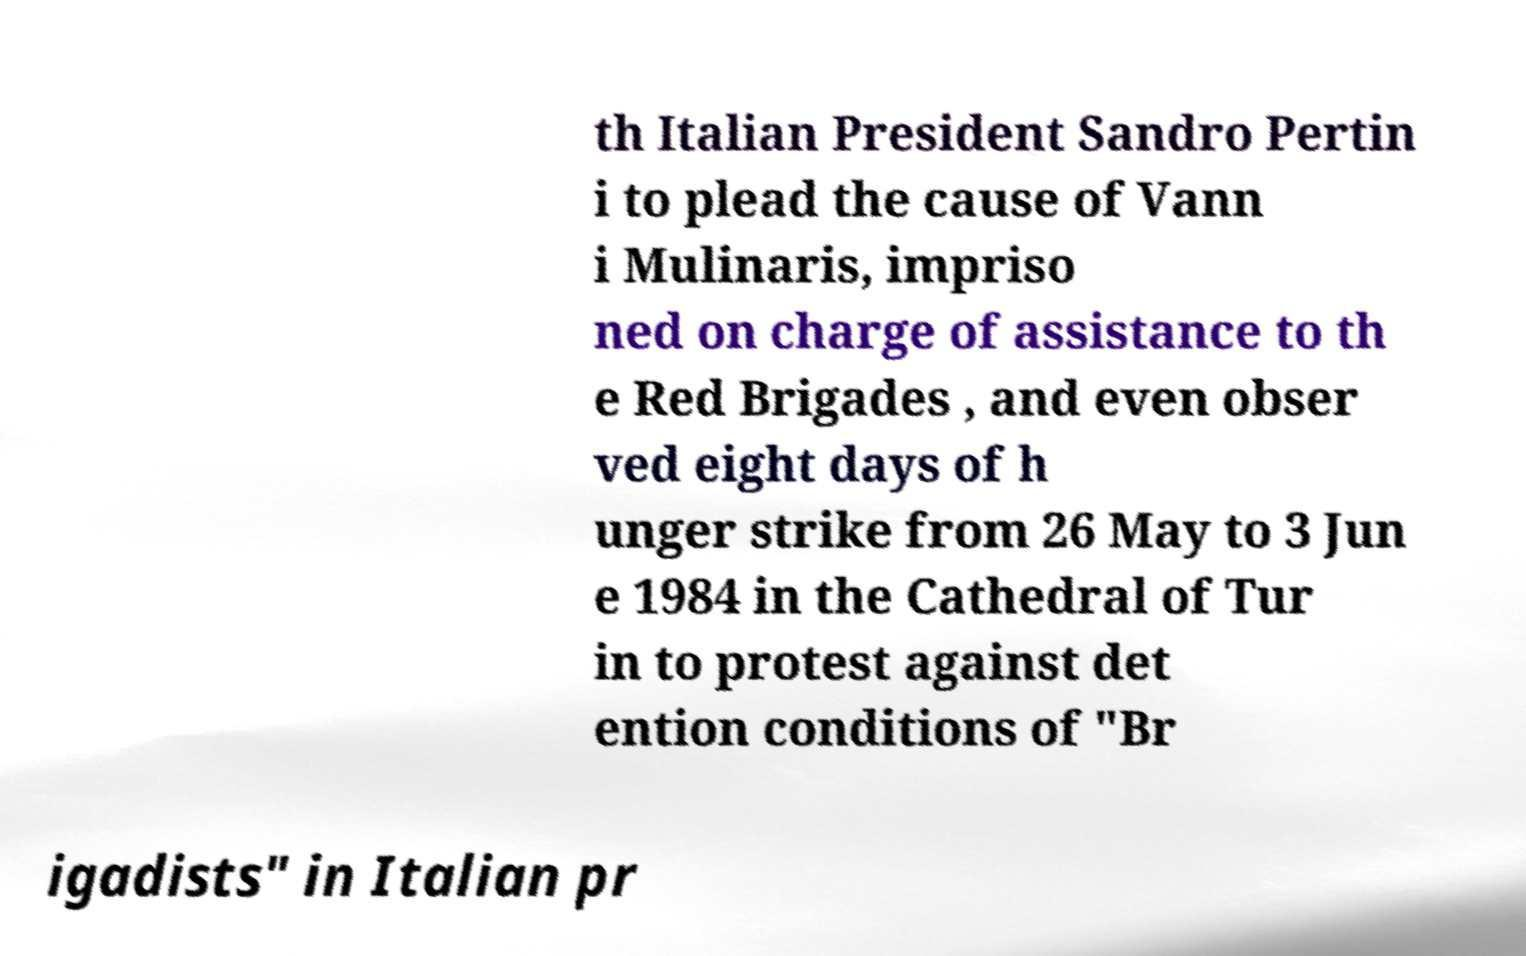Could you assist in decoding the text presented in this image and type it out clearly? th Italian President Sandro Pertin i to plead the cause of Vann i Mulinaris, impriso ned on charge of assistance to th e Red Brigades , and even obser ved eight days of h unger strike from 26 May to 3 Jun e 1984 in the Cathedral of Tur in to protest against det ention conditions of "Br igadists" in Italian pr 